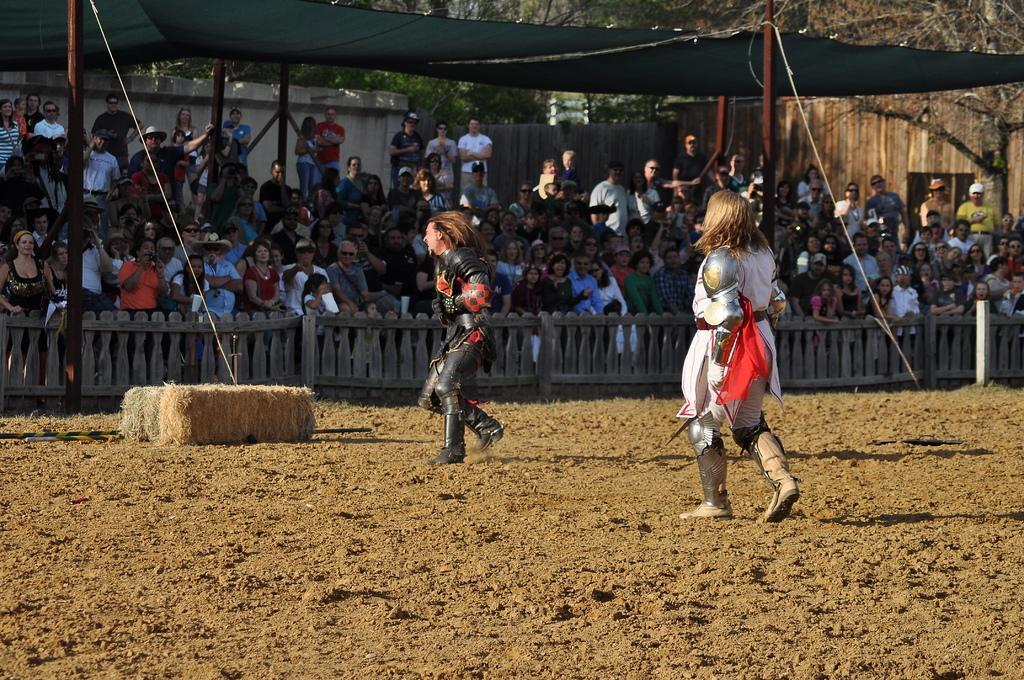Please provide a concise description of this image. In this image, we can see two humans are wearing different costumes and walking on the ground. Background we can see a group of people. Few are standing near the wooden fencing. Here we can see poles, tent, ropes, wooden wall and trees. 